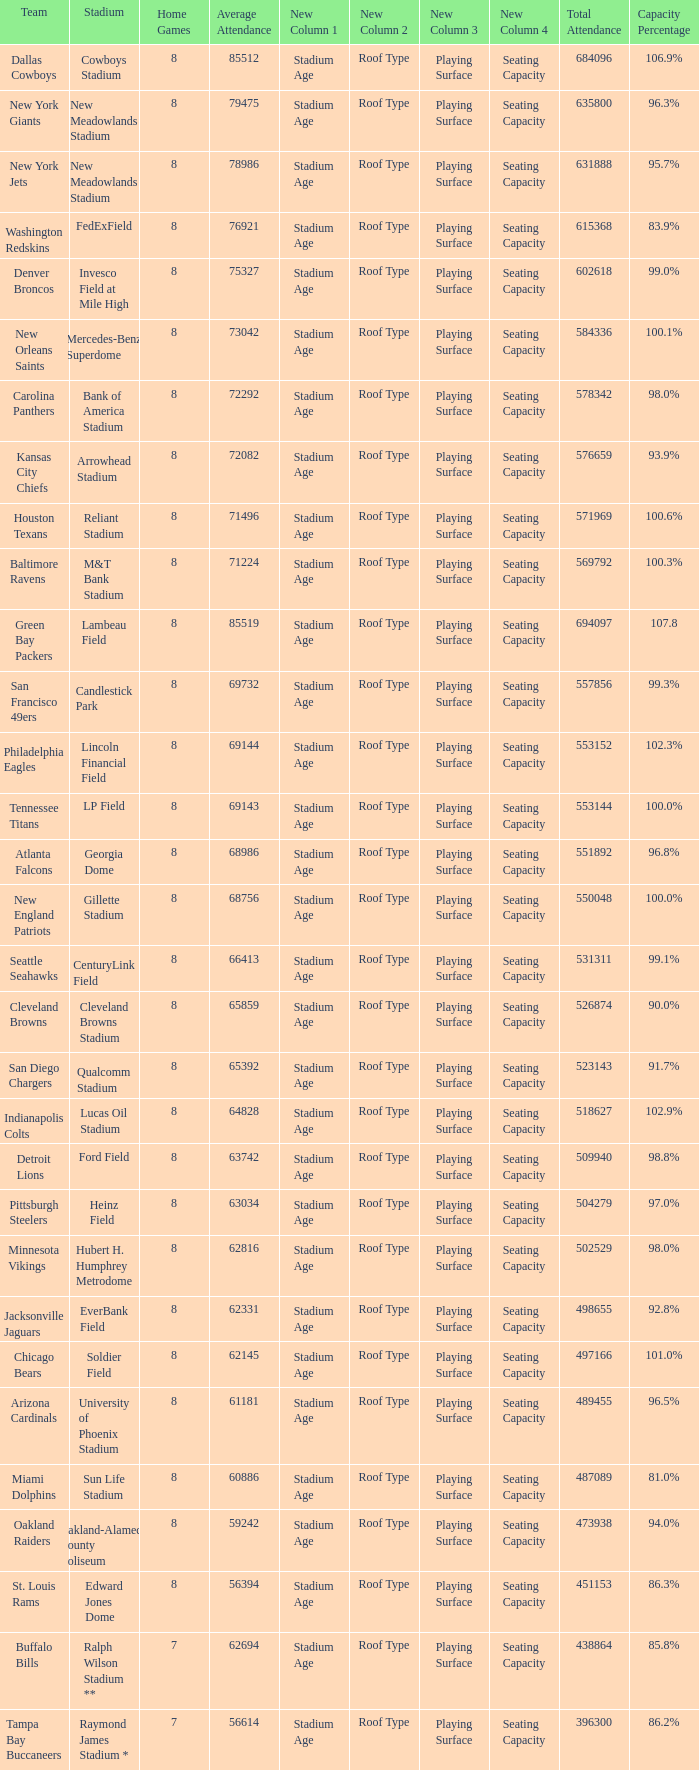What is the number listed in home games when the team is Seattle Seahawks? 8.0. 